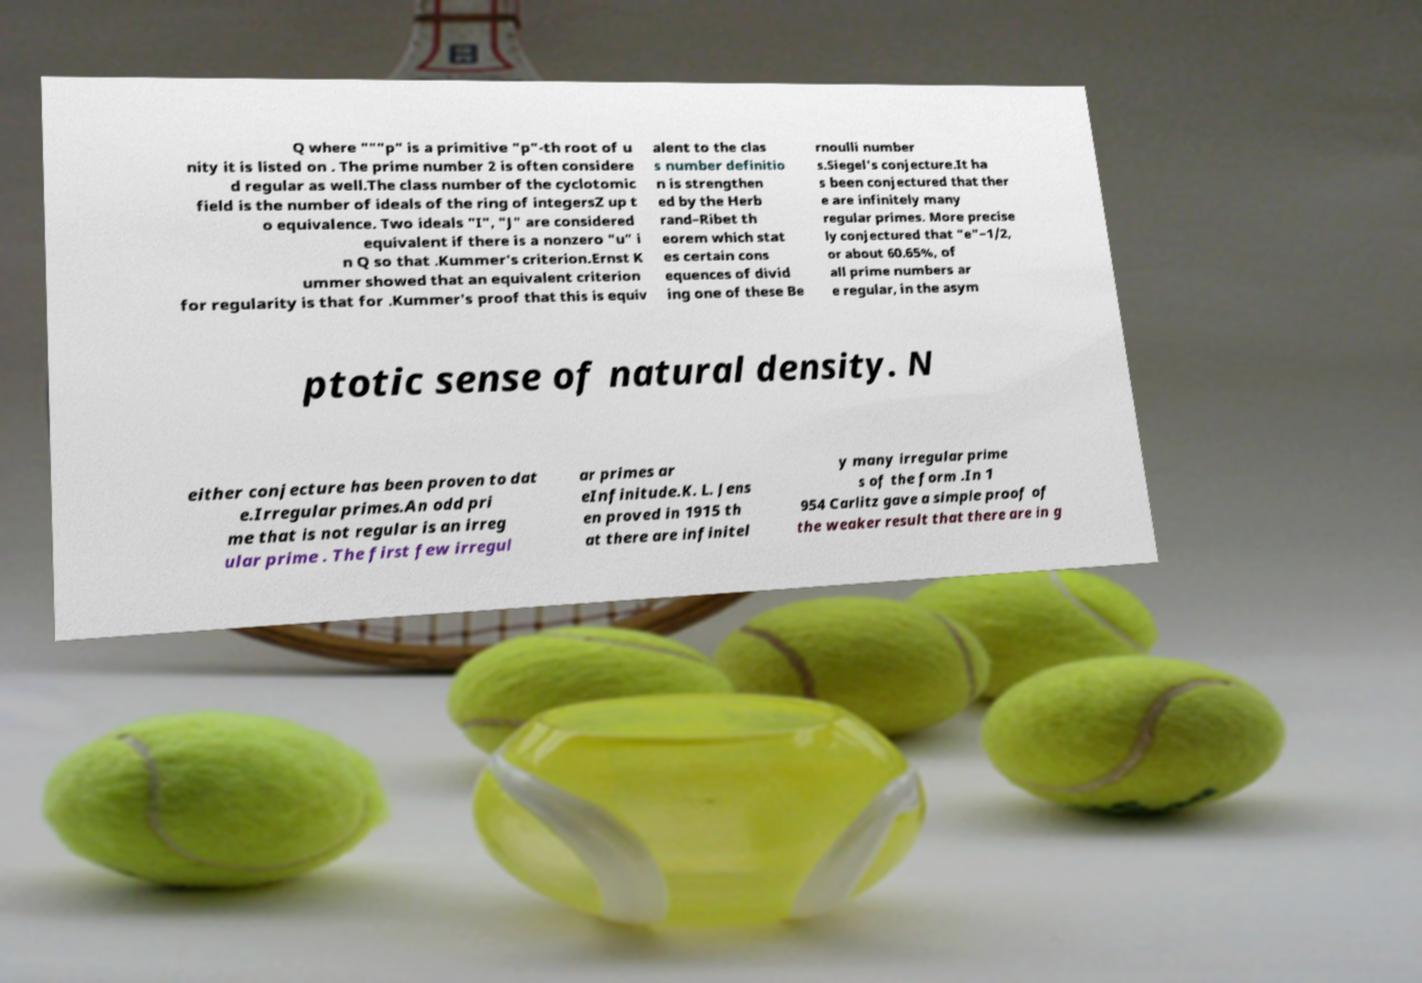Could you assist in decoding the text presented in this image and type it out clearly? Q where """p" is a primitive "p"-th root of u nity it is listed on . The prime number 2 is often considere d regular as well.The class number of the cyclotomic field is the number of ideals of the ring of integersZ up t o equivalence. Two ideals "I", "J" are considered equivalent if there is a nonzero "u" i n Q so that .Kummer's criterion.Ernst K ummer showed that an equivalent criterion for regularity is that for .Kummer's proof that this is equiv alent to the clas s number definitio n is strengthen ed by the Herb rand–Ribet th eorem which stat es certain cons equences of divid ing one of these Be rnoulli number s.Siegel's conjecture.It ha s been conjectured that ther e are infinitely many regular primes. More precise ly conjectured that "e"−1/2, or about 60.65%, of all prime numbers ar e regular, in the asym ptotic sense of natural density. N either conjecture has been proven to dat e.Irregular primes.An odd pri me that is not regular is an irreg ular prime . The first few irregul ar primes ar eInfinitude.K. L. Jens en proved in 1915 th at there are infinitel y many irregular prime s of the form .In 1 954 Carlitz gave a simple proof of the weaker result that there are in g 